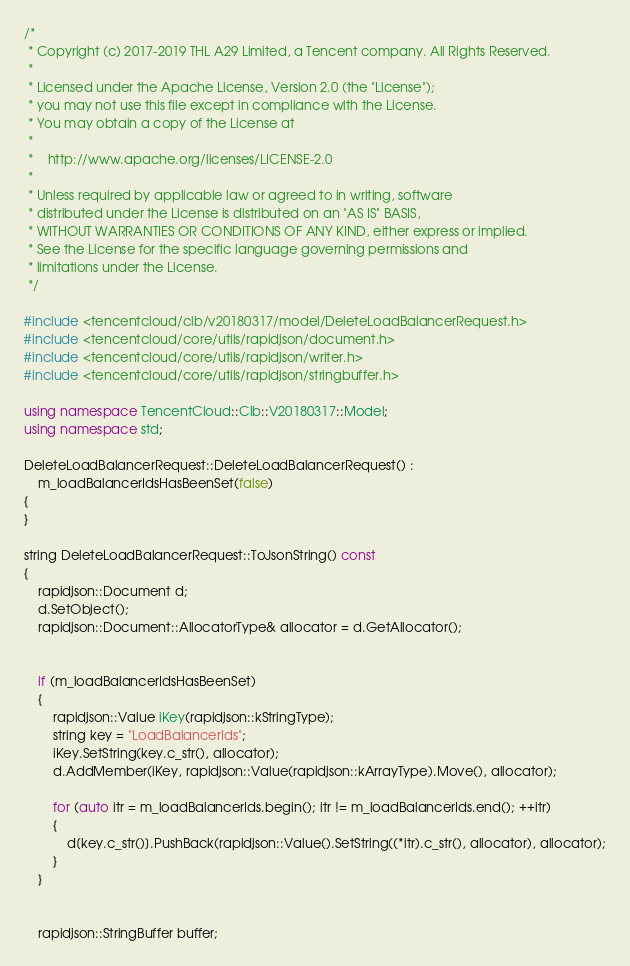Convert code to text. <code><loc_0><loc_0><loc_500><loc_500><_C++_>/*
 * Copyright (c) 2017-2019 THL A29 Limited, a Tencent company. All Rights Reserved.
 *
 * Licensed under the Apache License, Version 2.0 (the "License");
 * you may not use this file except in compliance with the License.
 * You may obtain a copy of the License at
 *
 *    http://www.apache.org/licenses/LICENSE-2.0
 *
 * Unless required by applicable law or agreed to in writing, software
 * distributed under the License is distributed on an "AS IS" BASIS,
 * WITHOUT WARRANTIES OR CONDITIONS OF ANY KIND, either express or implied.
 * See the License for the specific language governing permissions and
 * limitations under the License.
 */

#include <tencentcloud/clb/v20180317/model/DeleteLoadBalancerRequest.h>
#include <tencentcloud/core/utils/rapidjson/document.h>
#include <tencentcloud/core/utils/rapidjson/writer.h>
#include <tencentcloud/core/utils/rapidjson/stringbuffer.h>

using namespace TencentCloud::Clb::V20180317::Model;
using namespace std;

DeleteLoadBalancerRequest::DeleteLoadBalancerRequest() :
    m_loadBalancerIdsHasBeenSet(false)
{
}

string DeleteLoadBalancerRequest::ToJsonString() const
{
    rapidjson::Document d;
    d.SetObject();
    rapidjson::Document::AllocatorType& allocator = d.GetAllocator();


    if (m_loadBalancerIdsHasBeenSet)
    {
        rapidjson::Value iKey(rapidjson::kStringType);
        string key = "LoadBalancerIds";
        iKey.SetString(key.c_str(), allocator);
        d.AddMember(iKey, rapidjson::Value(rapidjson::kArrayType).Move(), allocator);

        for (auto itr = m_loadBalancerIds.begin(); itr != m_loadBalancerIds.end(); ++itr)
        {
            d[key.c_str()].PushBack(rapidjson::Value().SetString((*itr).c_str(), allocator), allocator);
        }
    }


    rapidjson::StringBuffer buffer;</code> 